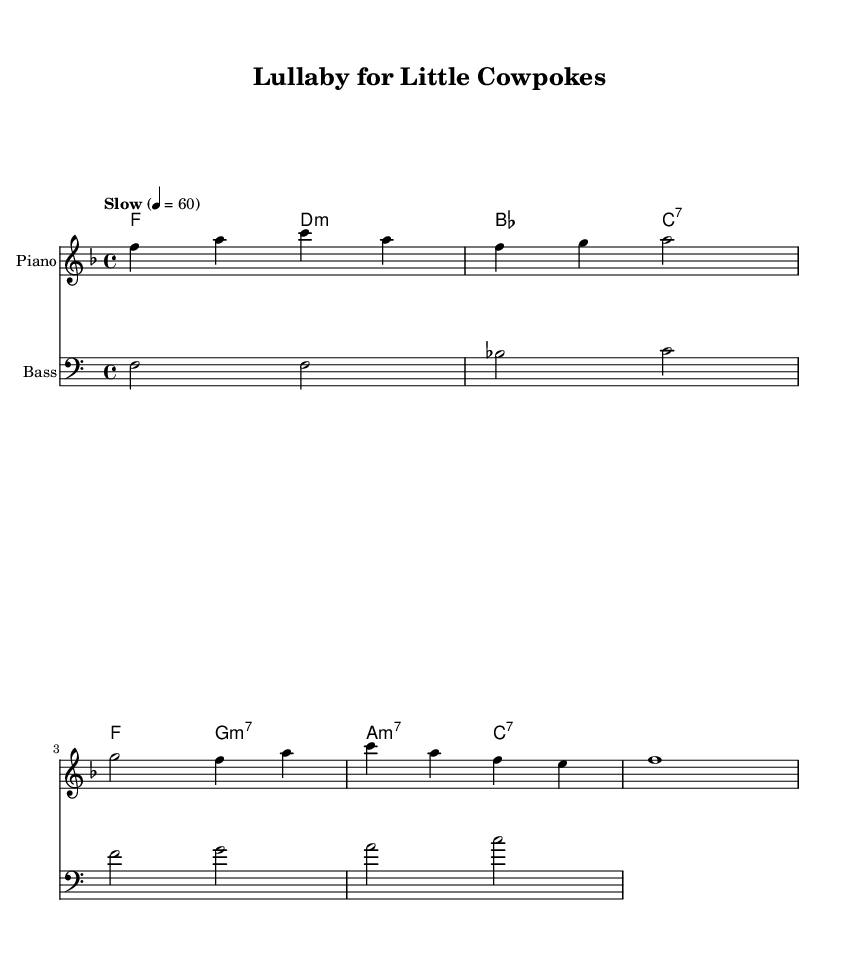What is the key signature of this music? The key signature shows one flat, which indicates that the piece is in F major.
Answer: F major What is the time signature of this music? The time signature is indicated at the beginning of the sheet music, displaying four beats per measure, which corresponds to a 4/4 time signature.
Answer: 4/4 What tempo is indicated in the music? The tempo marking at the beginning states "Slow" with a metronome marking of quarter note equals 60 beats per minute, suggesting a relaxed pace appropriate for a lullaby.
Answer: Slow, 60 How many measures are there in the melody? By counting the distinct bar lines in the melody section, there are four measures presented in the given melody.
Answer: Four What is the last note of the melody? The last note in the melody section is an F note, which can be identified at the end of the last measure.
Answer: F What type of chord progression is used in the harmonies? The chord progression utilizes several jazz chords, indicated by the symbols, including major, minor, and seventh chords, which are characteristic of jazz harmony.
Answer: Jazz chords What instruments are featured in this piece? The score indicates three distinct parts: a piano staff for the melody, a chord names staff for harmonies, and a bass staff, showing that the key instruments are piano and bass.
Answer: Piano and bass 